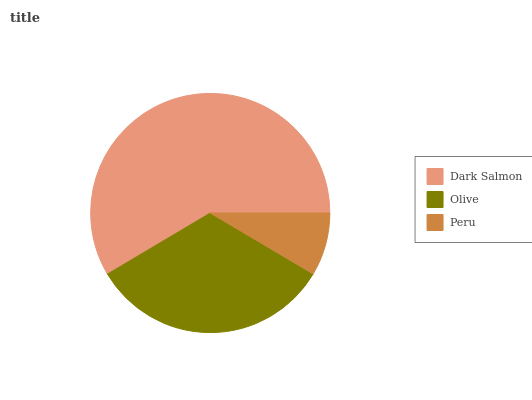Is Peru the minimum?
Answer yes or no. Yes. Is Dark Salmon the maximum?
Answer yes or no. Yes. Is Olive the minimum?
Answer yes or no. No. Is Olive the maximum?
Answer yes or no. No. Is Dark Salmon greater than Olive?
Answer yes or no. Yes. Is Olive less than Dark Salmon?
Answer yes or no. Yes. Is Olive greater than Dark Salmon?
Answer yes or no. No. Is Dark Salmon less than Olive?
Answer yes or no. No. Is Olive the high median?
Answer yes or no. Yes. Is Olive the low median?
Answer yes or no. Yes. Is Peru the high median?
Answer yes or no. No. Is Dark Salmon the low median?
Answer yes or no. No. 